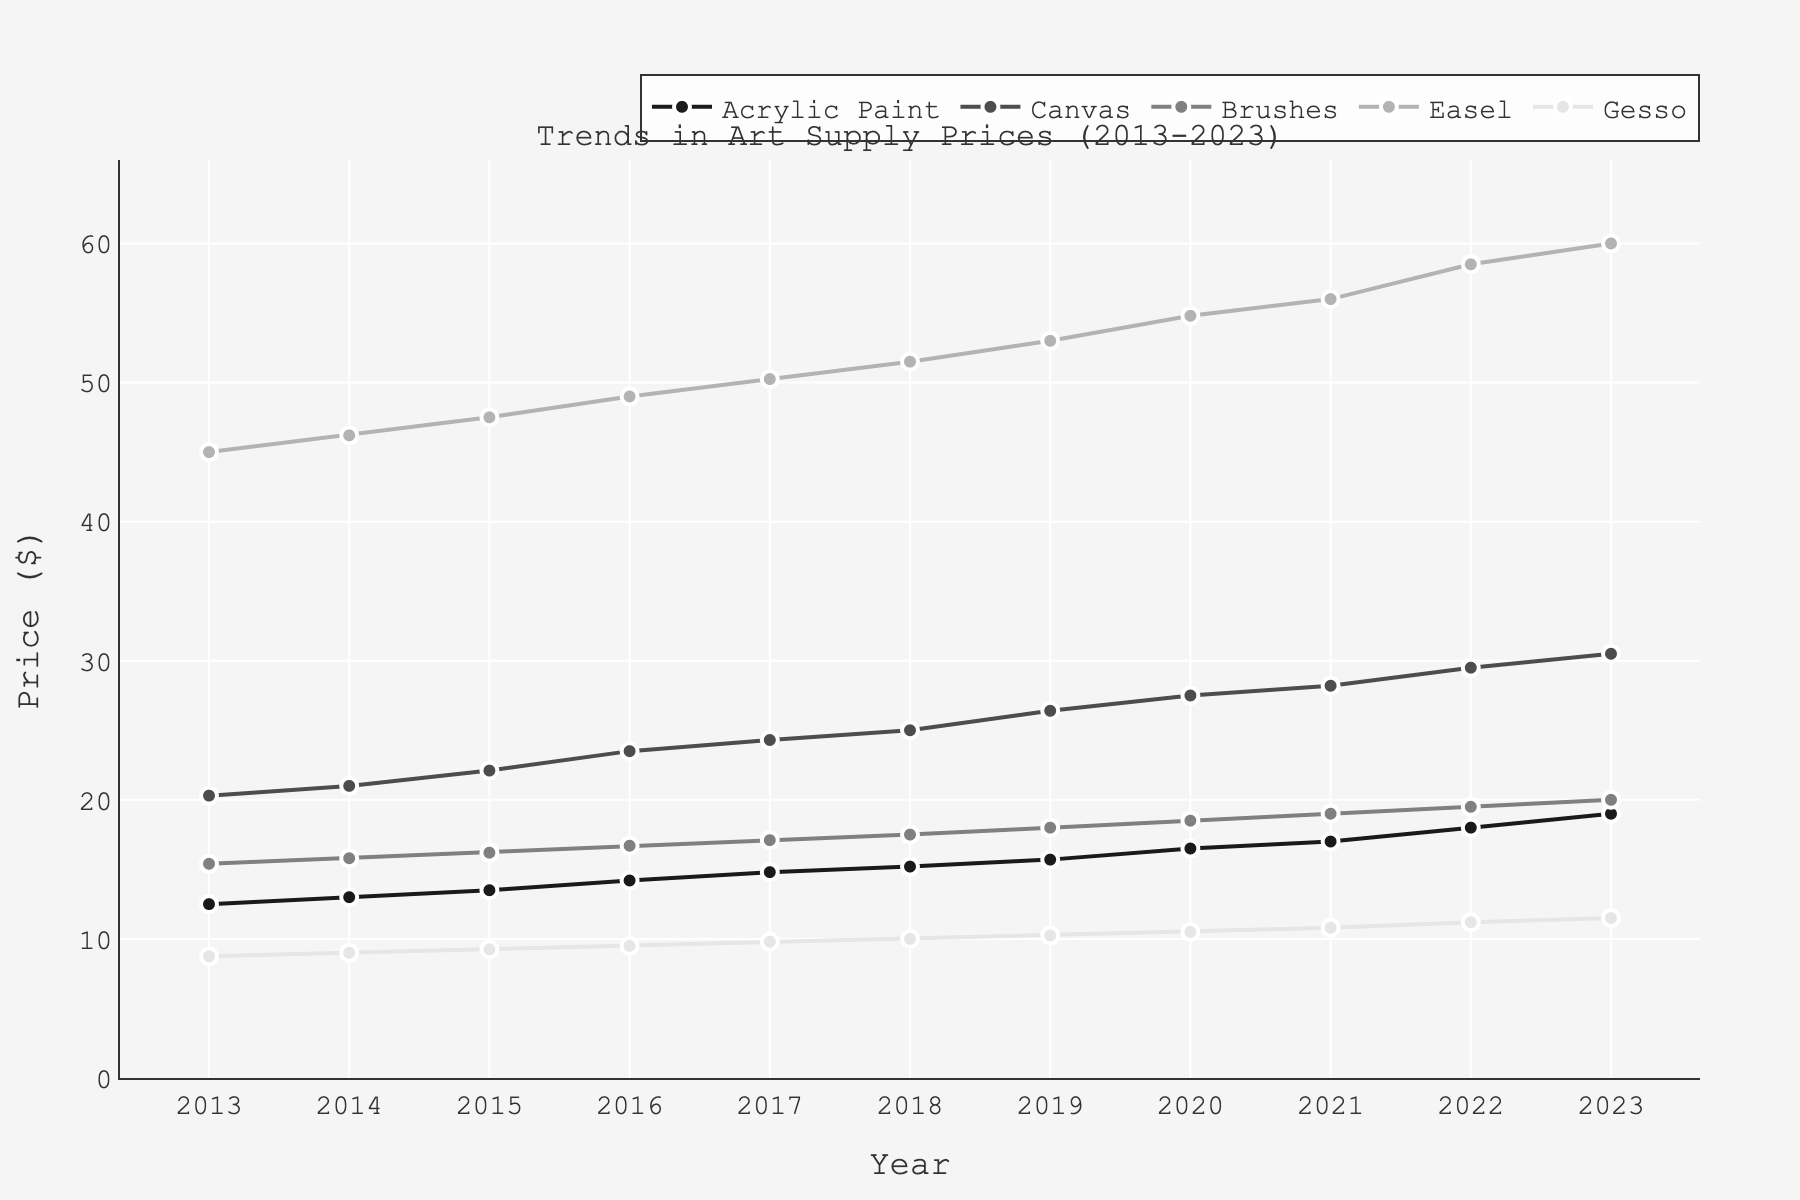What is the price of Acrylic Paint in 2023? The price of Acrylic Paint in 2023 is the value corresponding to the year 2023 on the Acrylic Paint line.
Answer: 19.00 Which art supply had the highest price in 2018? To find the highest price for 2018, check the prices of Acrylic Paint, Canvas, Brushes, Easel, and Gesso and identify the highest value. The Easel had the highest price.
Answer: Easel How did the price of Canvas change from 2013 to 2023? Compare the price of Canvas in 2013 and 2023. The price in 2013 was 20.30, and in 2023 it was 30.50.
Answer: Increased by 10.20 Which art supplies' prices exhibit a consistent upward trend over the decade? Observe the plotted lines for each art supply from 2013 to 2023 to check if each one consistently increases year by year. All art supplies (Acrylic Paint, Canvas, Brushes, Easel, and Gesso) show a consistent upward trend.
Answer: Acrylic Paint, Canvas, Brushes, Easel, Gesso How much did the price of Gesso increase from 2016 to 2020? Subtract the price of Gesso in 2016 (9.50) from its price in 2020 (10.50). The difference is 10.50 - 9.50.
Answer: 1.00 What year saw the highest price increase for Brushes? To find the year with the highest price increase for Brushes, calculate the year-over-year price change and find the maximum value. The highest increase is from 2020 to 2021, where the price went from 18.50 to 19.00.
Answer: 2020-2021 Compare the prices of Easel and Acrylic Paint in 2023. Which one is more expensive? The price of Easel in 2023 is 60.00, and the price of Acrylic Paint is 19.00. Easel is more expensive than Acrylic Paint.
Answer: Easel Calculate the average price of Canvas over the entire decade. Sum up the prices of Canvas from 2013 to 2023 (20.30 + 21.00 + 22.10 + 23.50 + 24.30 + 25.00 + 26.40 + 27.50 + 28.20 + 29.50 + 30.50) and divide by the number of years (11). Sum is 278.30; average is 278.30 / 11.
Answer: 25.30 Identify the years when Gesso's price rounded to the nearest dollar was 10. Find the years in which Gesso's price is 10 when rounded to the nearest dollar. The prices are closest to 10 in 2018 (10.00), 2019 (10.25), and 2020 (10.50).
Answer: 2018, 2019, 2020 